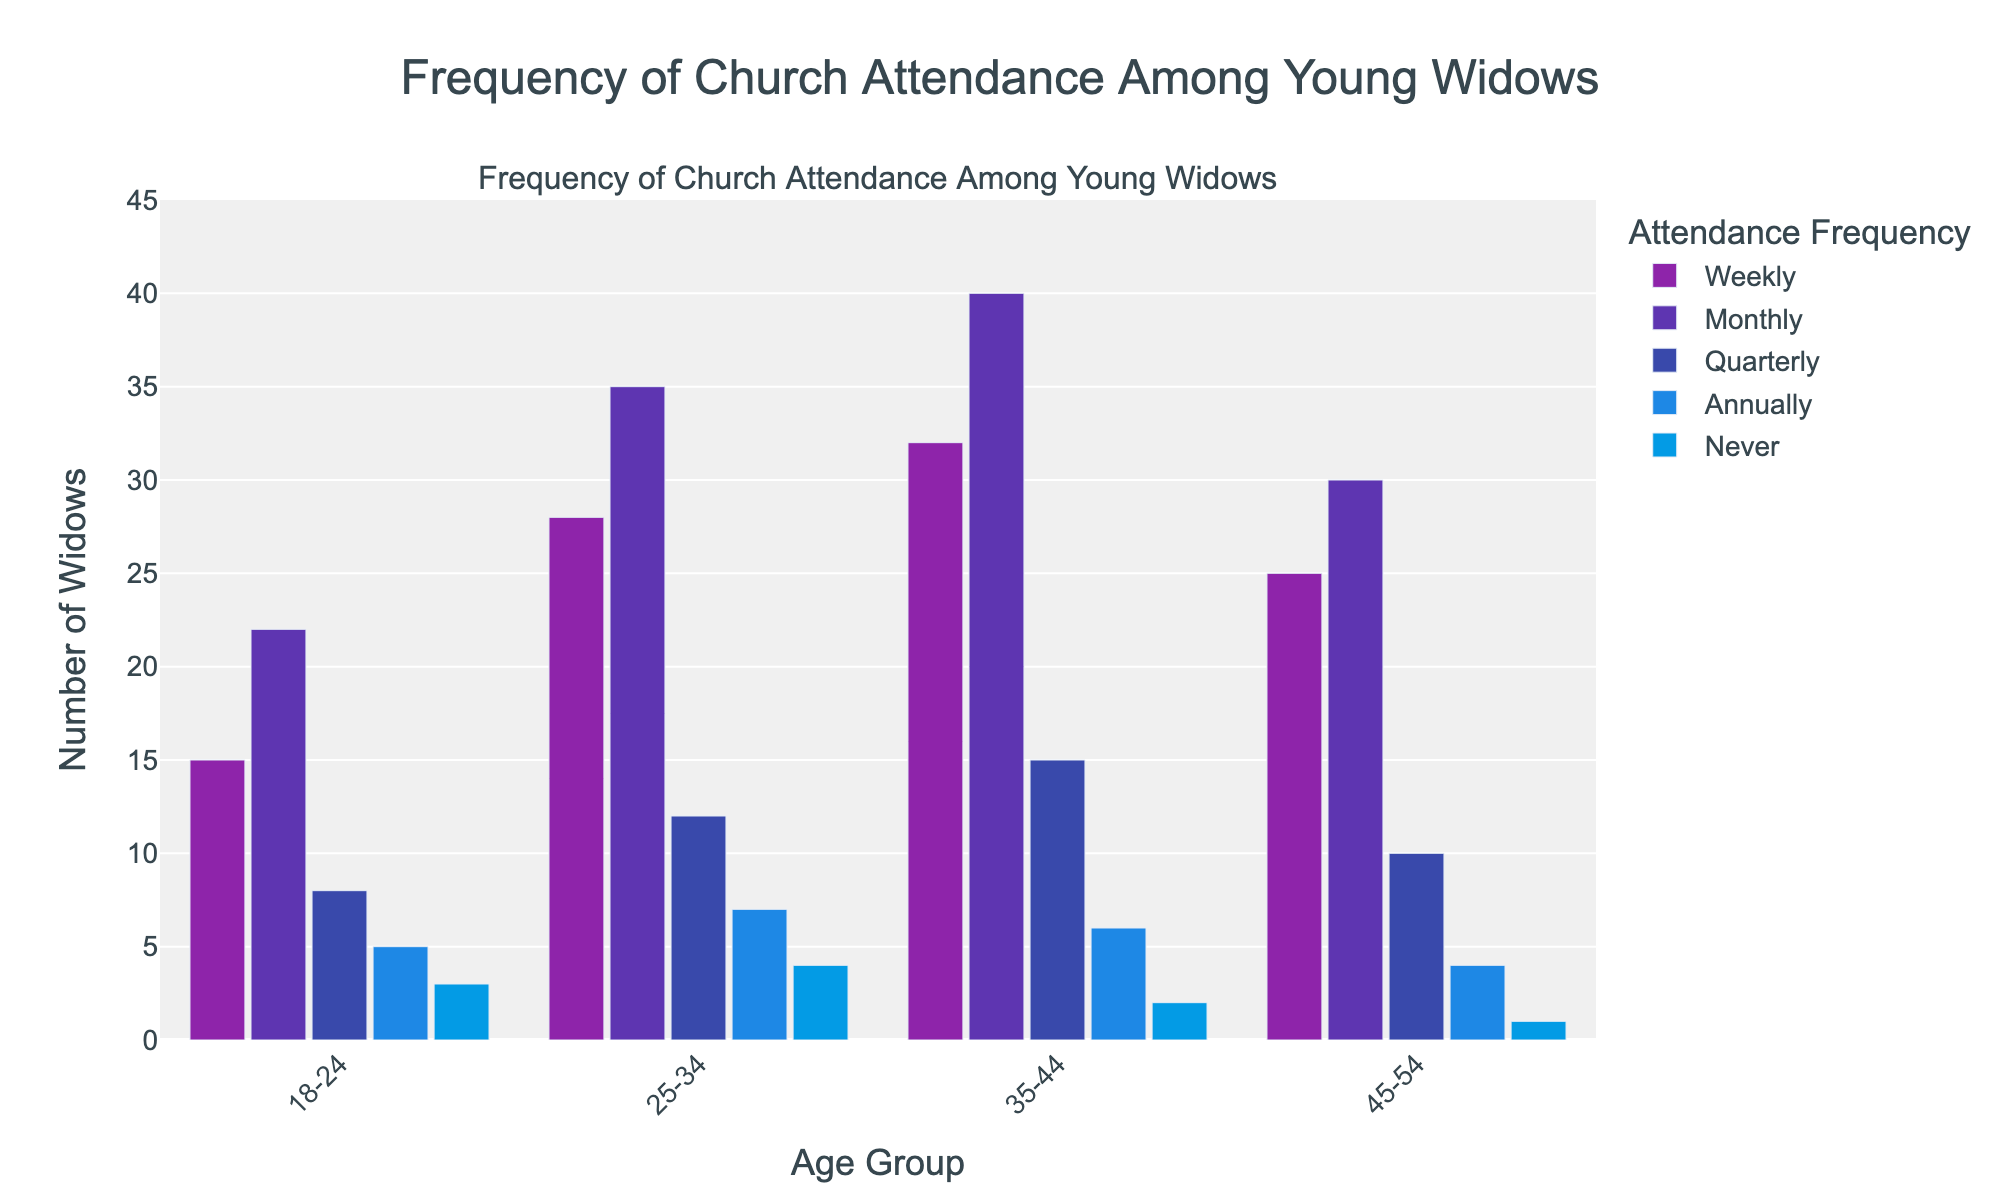How many age groups are presented in the figure? The figure has different bars arranged for varying age groups along the x-axis, each representing an age group. Counting the distinct groups, we find four: "18-24", "25-34", "35-44", and "45-54".
Answer: Four Which attendance frequency category has the highest count for the 25-34 age group? By observing the bars corresponding to the "25-34" age group, the tallest bar indicates the highest count for this age group. The "Monthly" category has the highest count.
Answer: Monthly How many widows in the 35-44 age group attend church quarterly or annually? We identify the bars representing "Quarterly" and "Annually" for the "35-44" age group and sum their counts: 15 (Quarterly) + 6 (Annually) = 21.
Answer: 21 What is the total number of young widows across all age groups who attend church monthly? Sum the counts of young widows who attend church monthly from each age group: 22 (18-24) + 35 (25-34) + 40 (35-44) + 30 (45-54) = 127.
Answer: 127 Among the age groups, which one has the largest number of widows who never attend church? By comparing the height of the bars labeled "Never" across all age groups, the tallest one is for "25-34" with a count of 4.
Answer: 25-34 For the 18-24 age group, what is the difference in the number of widows between those attending weekly and those attending annually? The number of widows attending church weekly is 15 and those attending annually is 5. The difference is calculated as 15 - 5 = 10.
Answer: 10 How many more widows in the 45-54 age group attend church weekly compared to those who never attend? In the "45-54" age group, the number attending weekly is 25, and the number who never attend is 1. The difference is 25 - 1 = 24.
Answer: 24 Which age group has the least number of widows attending church quarterly? By examining the "Quarterly" bars, the shortest one corresponds to the "18-24" age group with a count of 8.
Answer: 18-24 What is the average number of widows attending church annually across all age groups? Sum the counts of annual attendance from each age group and divide by the number of age groups: (5 + 7 + 6 + 4) / 4 = 22 / 4 = 5.5.
Answer: 5.5 Which age group has the highest overall frequency of church attendance (sum of all frequencies)? By summing the counts for each frequency in each age group, the group with the highest total is identified:
18-24: 15 + 22 + 8 + 5 + 3 = 53
25-34: 28 + 35 + 12 + 7 + 4 = 86
35-44: 32 + 40 + 15 + 6 + 2 = 95
45-54: 25 + 30 + 10 + 4 + 1 = 70
The "35-44" age group has the highest overall frequency.
Answer: 35-44 